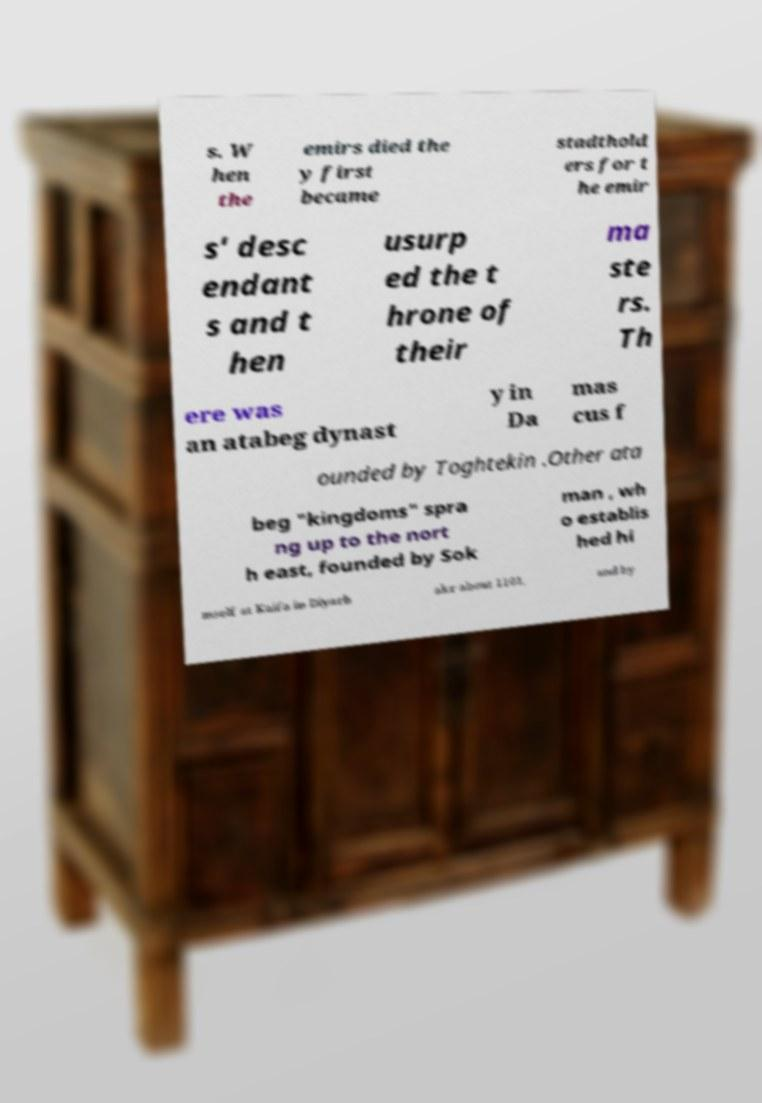I need the written content from this picture converted into text. Can you do that? s. W hen the emirs died the y first became stadthold ers for t he emir s' desc endant s and t hen usurp ed the t hrone of their ma ste rs. Th ere was an atabeg dynast y in Da mas cus f ounded by Toghtekin .Other ata beg "kingdoms" spra ng up to the nort h east, founded by Sok man , wh o establis hed hi mself at Kaifa in Diyarb akr about 1101, and by 